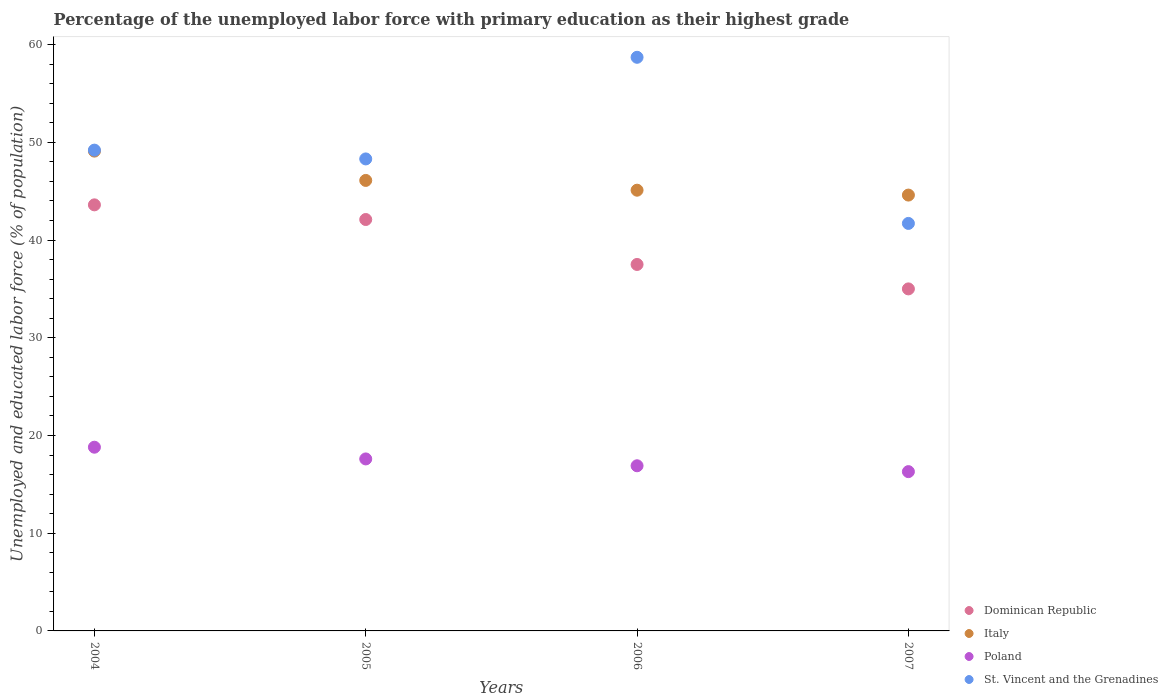How many different coloured dotlines are there?
Keep it short and to the point. 4. What is the percentage of the unemployed labor force with primary education in Italy in 2005?
Your answer should be very brief. 46.1. Across all years, what is the maximum percentage of the unemployed labor force with primary education in Dominican Republic?
Provide a short and direct response. 43.6. In which year was the percentage of the unemployed labor force with primary education in Italy maximum?
Your response must be concise. 2004. What is the total percentage of the unemployed labor force with primary education in Italy in the graph?
Make the answer very short. 184.9. What is the difference between the percentage of the unemployed labor force with primary education in Poland in 2004 and that in 2006?
Provide a short and direct response. 1.9. What is the difference between the percentage of the unemployed labor force with primary education in Dominican Republic in 2006 and the percentage of the unemployed labor force with primary education in St. Vincent and the Grenadines in 2005?
Provide a succinct answer. -10.8. What is the average percentage of the unemployed labor force with primary education in St. Vincent and the Grenadines per year?
Keep it short and to the point. 49.48. In the year 2005, what is the difference between the percentage of the unemployed labor force with primary education in Dominican Republic and percentage of the unemployed labor force with primary education in Poland?
Your answer should be compact. 24.5. In how many years, is the percentage of the unemployed labor force with primary education in Dominican Republic greater than 20 %?
Your answer should be very brief. 4. What is the ratio of the percentage of the unemployed labor force with primary education in Poland in 2006 to that in 2007?
Give a very brief answer. 1.04. Is the sum of the percentage of the unemployed labor force with primary education in Poland in 2006 and 2007 greater than the maximum percentage of the unemployed labor force with primary education in St. Vincent and the Grenadines across all years?
Your response must be concise. No. Is it the case that in every year, the sum of the percentage of the unemployed labor force with primary education in Dominican Republic and percentage of the unemployed labor force with primary education in Poland  is greater than the sum of percentage of the unemployed labor force with primary education in Italy and percentage of the unemployed labor force with primary education in St. Vincent and the Grenadines?
Make the answer very short. Yes. Does the percentage of the unemployed labor force with primary education in St. Vincent and the Grenadines monotonically increase over the years?
Offer a very short reply. No. How many dotlines are there?
Keep it short and to the point. 4. Are the values on the major ticks of Y-axis written in scientific E-notation?
Your response must be concise. No. Does the graph contain any zero values?
Provide a short and direct response. No. How are the legend labels stacked?
Offer a very short reply. Vertical. What is the title of the graph?
Your response must be concise. Percentage of the unemployed labor force with primary education as their highest grade. Does "Dominica" appear as one of the legend labels in the graph?
Make the answer very short. No. What is the label or title of the X-axis?
Your response must be concise. Years. What is the label or title of the Y-axis?
Provide a succinct answer. Unemployed and educated labor force (% of population). What is the Unemployed and educated labor force (% of population) in Dominican Republic in 2004?
Make the answer very short. 43.6. What is the Unemployed and educated labor force (% of population) of Italy in 2004?
Give a very brief answer. 49.1. What is the Unemployed and educated labor force (% of population) of Poland in 2004?
Ensure brevity in your answer.  18.8. What is the Unemployed and educated labor force (% of population) of St. Vincent and the Grenadines in 2004?
Give a very brief answer. 49.2. What is the Unemployed and educated labor force (% of population) in Dominican Republic in 2005?
Make the answer very short. 42.1. What is the Unemployed and educated labor force (% of population) in Italy in 2005?
Keep it short and to the point. 46.1. What is the Unemployed and educated labor force (% of population) in Poland in 2005?
Keep it short and to the point. 17.6. What is the Unemployed and educated labor force (% of population) in St. Vincent and the Grenadines in 2005?
Provide a succinct answer. 48.3. What is the Unemployed and educated labor force (% of population) in Dominican Republic in 2006?
Ensure brevity in your answer.  37.5. What is the Unemployed and educated labor force (% of population) in Italy in 2006?
Offer a terse response. 45.1. What is the Unemployed and educated labor force (% of population) in Poland in 2006?
Your answer should be compact. 16.9. What is the Unemployed and educated labor force (% of population) in St. Vincent and the Grenadines in 2006?
Provide a succinct answer. 58.7. What is the Unemployed and educated labor force (% of population) of Dominican Republic in 2007?
Offer a terse response. 35. What is the Unemployed and educated labor force (% of population) of Italy in 2007?
Provide a short and direct response. 44.6. What is the Unemployed and educated labor force (% of population) in Poland in 2007?
Ensure brevity in your answer.  16.3. What is the Unemployed and educated labor force (% of population) in St. Vincent and the Grenadines in 2007?
Your answer should be compact. 41.7. Across all years, what is the maximum Unemployed and educated labor force (% of population) of Dominican Republic?
Your answer should be compact. 43.6. Across all years, what is the maximum Unemployed and educated labor force (% of population) of Italy?
Your response must be concise. 49.1. Across all years, what is the maximum Unemployed and educated labor force (% of population) in Poland?
Keep it short and to the point. 18.8. Across all years, what is the maximum Unemployed and educated labor force (% of population) in St. Vincent and the Grenadines?
Offer a very short reply. 58.7. Across all years, what is the minimum Unemployed and educated labor force (% of population) in Dominican Republic?
Keep it short and to the point. 35. Across all years, what is the minimum Unemployed and educated labor force (% of population) in Italy?
Make the answer very short. 44.6. Across all years, what is the minimum Unemployed and educated labor force (% of population) of Poland?
Your answer should be compact. 16.3. Across all years, what is the minimum Unemployed and educated labor force (% of population) in St. Vincent and the Grenadines?
Offer a terse response. 41.7. What is the total Unemployed and educated labor force (% of population) of Dominican Republic in the graph?
Provide a short and direct response. 158.2. What is the total Unemployed and educated labor force (% of population) of Italy in the graph?
Keep it short and to the point. 184.9. What is the total Unemployed and educated labor force (% of population) in Poland in the graph?
Give a very brief answer. 69.6. What is the total Unemployed and educated labor force (% of population) in St. Vincent and the Grenadines in the graph?
Your response must be concise. 197.9. What is the difference between the Unemployed and educated labor force (% of population) in Dominican Republic in 2004 and that in 2005?
Provide a succinct answer. 1.5. What is the difference between the Unemployed and educated labor force (% of population) of Italy in 2004 and that in 2006?
Give a very brief answer. 4. What is the difference between the Unemployed and educated labor force (% of population) in Poland in 2004 and that in 2006?
Keep it short and to the point. 1.9. What is the difference between the Unemployed and educated labor force (% of population) of Dominican Republic in 2004 and that in 2007?
Offer a terse response. 8.6. What is the difference between the Unemployed and educated labor force (% of population) in Italy in 2004 and that in 2007?
Provide a succinct answer. 4.5. What is the difference between the Unemployed and educated labor force (% of population) in Poland in 2004 and that in 2007?
Your answer should be very brief. 2.5. What is the difference between the Unemployed and educated labor force (% of population) in St. Vincent and the Grenadines in 2004 and that in 2007?
Your answer should be very brief. 7.5. What is the difference between the Unemployed and educated labor force (% of population) in Dominican Republic in 2005 and that in 2006?
Give a very brief answer. 4.6. What is the difference between the Unemployed and educated labor force (% of population) in Italy in 2005 and that in 2006?
Give a very brief answer. 1. What is the difference between the Unemployed and educated labor force (% of population) of St. Vincent and the Grenadines in 2005 and that in 2006?
Give a very brief answer. -10.4. What is the difference between the Unemployed and educated labor force (% of population) in Dominican Republic in 2005 and that in 2007?
Give a very brief answer. 7.1. What is the difference between the Unemployed and educated labor force (% of population) of Poland in 2005 and that in 2007?
Give a very brief answer. 1.3. What is the difference between the Unemployed and educated labor force (% of population) of St. Vincent and the Grenadines in 2005 and that in 2007?
Keep it short and to the point. 6.6. What is the difference between the Unemployed and educated labor force (% of population) of Dominican Republic in 2006 and that in 2007?
Keep it short and to the point. 2.5. What is the difference between the Unemployed and educated labor force (% of population) in Poland in 2006 and that in 2007?
Your response must be concise. 0.6. What is the difference between the Unemployed and educated labor force (% of population) of St. Vincent and the Grenadines in 2006 and that in 2007?
Offer a very short reply. 17. What is the difference between the Unemployed and educated labor force (% of population) of Dominican Republic in 2004 and the Unemployed and educated labor force (% of population) of Italy in 2005?
Provide a succinct answer. -2.5. What is the difference between the Unemployed and educated labor force (% of population) of Dominican Republic in 2004 and the Unemployed and educated labor force (% of population) of Poland in 2005?
Give a very brief answer. 26. What is the difference between the Unemployed and educated labor force (% of population) in Italy in 2004 and the Unemployed and educated labor force (% of population) in Poland in 2005?
Your answer should be very brief. 31.5. What is the difference between the Unemployed and educated labor force (% of population) of Italy in 2004 and the Unemployed and educated labor force (% of population) of St. Vincent and the Grenadines in 2005?
Your answer should be compact. 0.8. What is the difference between the Unemployed and educated labor force (% of population) of Poland in 2004 and the Unemployed and educated labor force (% of population) of St. Vincent and the Grenadines in 2005?
Provide a succinct answer. -29.5. What is the difference between the Unemployed and educated labor force (% of population) in Dominican Republic in 2004 and the Unemployed and educated labor force (% of population) in Poland in 2006?
Give a very brief answer. 26.7. What is the difference between the Unemployed and educated labor force (% of population) of Dominican Republic in 2004 and the Unemployed and educated labor force (% of population) of St. Vincent and the Grenadines in 2006?
Give a very brief answer. -15.1. What is the difference between the Unemployed and educated labor force (% of population) of Italy in 2004 and the Unemployed and educated labor force (% of population) of Poland in 2006?
Offer a terse response. 32.2. What is the difference between the Unemployed and educated labor force (% of population) in Poland in 2004 and the Unemployed and educated labor force (% of population) in St. Vincent and the Grenadines in 2006?
Offer a terse response. -39.9. What is the difference between the Unemployed and educated labor force (% of population) in Dominican Republic in 2004 and the Unemployed and educated labor force (% of population) in Poland in 2007?
Give a very brief answer. 27.3. What is the difference between the Unemployed and educated labor force (% of population) in Dominican Republic in 2004 and the Unemployed and educated labor force (% of population) in St. Vincent and the Grenadines in 2007?
Your response must be concise. 1.9. What is the difference between the Unemployed and educated labor force (% of population) of Italy in 2004 and the Unemployed and educated labor force (% of population) of Poland in 2007?
Keep it short and to the point. 32.8. What is the difference between the Unemployed and educated labor force (% of population) in Poland in 2004 and the Unemployed and educated labor force (% of population) in St. Vincent and the Grenadines in 2007?
Give a very brief answer. -22.9. What is the difference between the Unemployed and educated labor force (% of population) in Dominican Republic in 2005 and the Unemployed and educated labor force (% of population) in Italy in 2006?
Provide a succinct answer. -3. What is the difference between the Unemployed and educated labor force (% of population) in Dominican Republic in 2005 and the Unemployed and educated labor force (% of population) in Poland in 2006?
Make the answer very short. 25.2. What is the difference between the Unemployed and educated labor force (% of population) of Dominican Republic in 2005 and the Unemployed and educated labor force (% of population) of St. Vincent and the Grenadines in 2006?
Provide a succinct answer. -16.6. What is the difference between the Unemployed and educated labor force (% of population) in Italy in 2005 and the Unemployed and educated labor force (% of population) in Poland in 2006?
Provide a short and direct response. 29.2. What is the difference between the Unemployed and educated labor force (% of population) in Italy in 2005 and the Unemployed and educated labor force (% of population) in St. Vincent and the Grenadines in 2006?
Make the answer very short. -12.6. What is the difference between the Unemployed and educated labor force (% of population) of Poland in 2005 and the Unemployed and educated labor force (% of population) of St. Vincent and the Grenadines in 2006?
Your response must be concise. -41.1. What is the difference between the Unemployed and educated labor force (% of population) of Dominican Republic in 2005 and the Unemployed and educated labor force (% of population) of Poland in 2007?
Make the answer very short. 25.8. What is the difference between the Unemployed and educated labor force (% of population) of Italy in 2005 and the Unemployed and educated labor force (% of population) of Poland in 2007?
Offer a very short reply. 29.8. What is the difference between the Unemployed and educated labor force (% of population) in Poland in 2005 and the Unemployed and educated labor force (% of population) in St. Vincent and the Grenadines in 2007?
Provide a short and direct response. -24.1. What is the difference between the Unemployed and educated labor force (% of population) in Dominican Republic in 2006 and the Unemployed and educated labor force (% of population) in Poland in 2007?
Your answer should be compact. 21.2. What is the difference between the Unemployed and educated labor force (% of population) in Italy in 2006 and the Unemployed and educated labor force (% of population) in Poland in 2007?
Your response must be concise. 28.8. What is the difference between the Unemployed and educated labor force (% of population) in Italy in 2006 and the Unemployed and educated labor force (% of population) in St. Vincent and the Grenadines in 2007?
Provide a short and direct response. 3.4. What is the difference between the Unemployed and educated labor force (% of population) of Poland in 2006 and the Unemployed and educated labor force (% of population) of St. Vincent and the Grenadines in 2007?
Offer a very short reply. -24.8. What is the average Unemployed and educated labor force (% of population) in Dominican Republic per year?
Provide a short and direct response. 39.55. What is the average Unemployed and educated labor force (% of population) in Italy per year?
Provide a succinct answer. 46.23. What is the average Unemployed and educated labor force (% of population) in St. Vincent and the Grenadines per year?
Provide a short and direct response. 49.48. In the year 2004, what is the difference between the Unemployed and educated labor force (% of population) of Dominican Republic and Unemployed and educated labor force (% of population) of Poland?
Provide a succinct answer. 24.8. In the year 2004, what is the difference between the Unemployed and educated labor force (% of population) in Italy and Unemployed and educated labor force (% of population) in Poland?
Give a very brief answer. 30.3. In the year 2004, what is the difference between the Unemployed and educated labor force (% of population) in Poland and Unemployed and educated labor force (% of population) in St. Vincent and the Grenadines?
Your response must be concise. -30.4. In the year 2005, what is the difference between the Unemployed and educated labor force (% of population) of Dominican Republic and Unemployed and educated labor force (% of population) of Italy?
Keep it short and to the point. -4. In the year 2005, what is the difference between the Unemployed and educated labor force (% of population) of Dominican Republic and Unemployed and educated labor force (% of population) of Poland?
Give a very brief answer. 24.5. In the year 2005, what is the difference between the Unemployed and educated labor force (% of population) in Dominican Republic and Unemployed and educated labor force (% of population) in St. Vincent and the Grenadines?
Offer a very short reply. -6.2. In the year 2005, what is the difference between the Unemployed and educated labor force (% of population) in Poland and Unemployed and educated labor force (% of population) in St. Vincent and the Grenadines?
Your response must be concise. -30.7. In the year 2006, what is the difference between the Unemployed and educated labor force (% of population) of Dominican Republic and Unemployed and educated labor force (% of population) of Poland?
Provide a succinct answer. 20.6. In the year 2006, what is the difference between the Unemployed and educated labor force (% of population) of Dominican Republic and Unemployed and educated labor force (% of population) of St. Vincent and the Grenadines?
Ensure brevity in your answer.  -21.2. In the year 2006, what is the difference between the Unemployed and educated labor force (% of population) of Italy and Unemployed and educated labor force (% of population) of Poland?
Ensure brevity in your answer.  28.2. In the year 2006, what is the difference between the Unemployed and educated labor force (% of population) in Italy and Unemployed and educated labor force (% of population) in St. Vincent and the Grenadines?
Provide a succinct answer. -13.6. In the year 2006, what is the difference between the Unemployed and educated labor force (% of population) in Poland and Unemployed and educated labor force (% of population) in St. Vincent and the Grenadines?
Your response must be concise. -41.8. In the year 2007, what is the difference between the Unemployed and educated labor force (% of population) in Dominican Republic and Unemployed and educated labor force (% of population) in Poland?
Offer a terse response. 18.7. In the year 2007, what is the difference between the Unemployed and educated labor force (% of population) of Italy and Unemployed and educated labor force (% of population) of Poland?
Give a very brief answer. 28.3. In the year 2007, what is the difference between the Unemployed and educated labor force (% of population) in Poland and Unemployed and educated labor force (% of population) in St. Vincent and the Grenadines?
Offer a terse response. -25.4. What is the ratio of the Unemployed and educated labor force (% of population) of Dominican Republic in 2004 to that in 2005?
Your answer should be very brief. 1.04. What is the ratio of the Unemployed and educated labor force (% of population) in Italy in 2004 to that in 2005?
Give a very brief answer. 1.07. What is the ratio of the Unemployed and educated labor force (% of population) of Poland in 2004 to that in 2005?
Your answer should be very brief. 1.07. What is the ratio of the Unemployed and educated labor force (% of population) of St. Vincent and the Grenadines in 2004 to that in 2005?
Your answer should be very brief. 1.02. What is the ratio of the Unemployed and educated labor force (% of population) of Dominican Republic in 2004 to that in 2006?
Your response must be concise. 1.16. What is the ratio of the Unemployed and educated labor force (% of population) in Italy in 2004 to that in 2006?
Your answer should be very brief. 1.09. What is the ratio of the Unemployed and educated labor force (% of population) in Poland in 2004 to that in 2006?
Your answer should be compact. 1.11. What is the ratio of the Unemployed and educated labor force (% of population) in St. Vincent and the Grenadines in 2004 to that in 2006?
Provide a short and direct response. 0.84. What is the ratio of the Unemployed and educated labor force (% of population) of Dominican Republic in 2004 to that in 2007?
Your answer should be compact. 1.25. What is the ratio of the Unemployed and educated labor force (% of population) of Italy in 2004 to that in 2007?
Your response must be concise. 1.1. What is the ratio of the Unemployed and educated labor force (% of population) in Poland in 2004 to that in 2007?
Offer a terse response. 1.15. What is the ratio of the Unemployed and educated labor force (% of population) of St. Vincent and the Grenadines in 2004 to that in 2007?
Give a very brief answer. 1.18. What is the ratio of the Unemployed and educated labor force (% of population) in Dominican Republic in 2005 to that in 2006?
Ensure brevity in your answer.  1.12. What is the ratio of the Unemployed and educated labor force (% of population) of Italy in 2005 to that in 2006?
Give a very brief answer. 1.02. What is the ratio of the Unemployed and educated labor force (% of population) of Poland in 2005 to that in 2006?
Provide a short and direct response. 1.04. What is the ratio of the Unemployed and educated labor force (% of population) in St. Vincent and the Grenadines in 2005 to that in 2006?
Give a very brief answer. 0.82. What is the ratio of the Unemployed and educated labor force (% of population) of Dominican Republic in 2005 to that in 2007?
Keep it short and to the point. 1.2. What is the ratio of the Unemployed and educated labor force (% of population) in Italy in 2005 to that in 2007?
Make the answer very short. 1.03. What is the ratio of the Unemployed and educated labor force (% of population) in Poland in 2005 to that in 2007?
Make the answer very short. 1.08. What is the ratio of the Unemployed and educated labor force (% of population) in St. Vincent and the Grenadines in 2005 to that in 2007?
Give a very brief answer. 1.16. What is the ratio of the Unemployed and educated labor force (% of population) of Dominican Republic in 2006 to that in 2007?
Make the answer very short. 1.07. What is the ratio of the Unemployed and educated labor force (% of population) in Italy in 2006 to that in 2007?
Your answer should be compact. 1.01. What is the ratio of the Unemployed and educated labor force (% of population) in Poland in 2006 to that in 2007?
Your answer should be very brief. 1.04. What is the ratio of the Unemployed and educated labor force (% of population) in St. Vincent and the Grenadines in 2006 to that in 2007?
Ensure brevity in your answer.  1.41. What is the difference between the highest and the second highest Unemployed and educated labor force (% of population) of Dominican Republic?
Your response must be concise. 1.5. What is the difference between the highest and the second highest Unemployed and educated labor force (% of population) in Italy?
Your answer should be compact. 3. What is the difference between the highest and the second highest Unemployed and educated labor force (% of population) in Poland?
Provide a succinct answer. 1.2. What is the difference between the highest and the second highest Unemployed and educated labor force (% of population) in St. Vincent and the Grenadines?
Provide a succinct answer. 9.5. What is the difference between the highest and the lowest Unemployed and educated labor force (% of population) of Italy?
Offer a terse response. 4.5. 